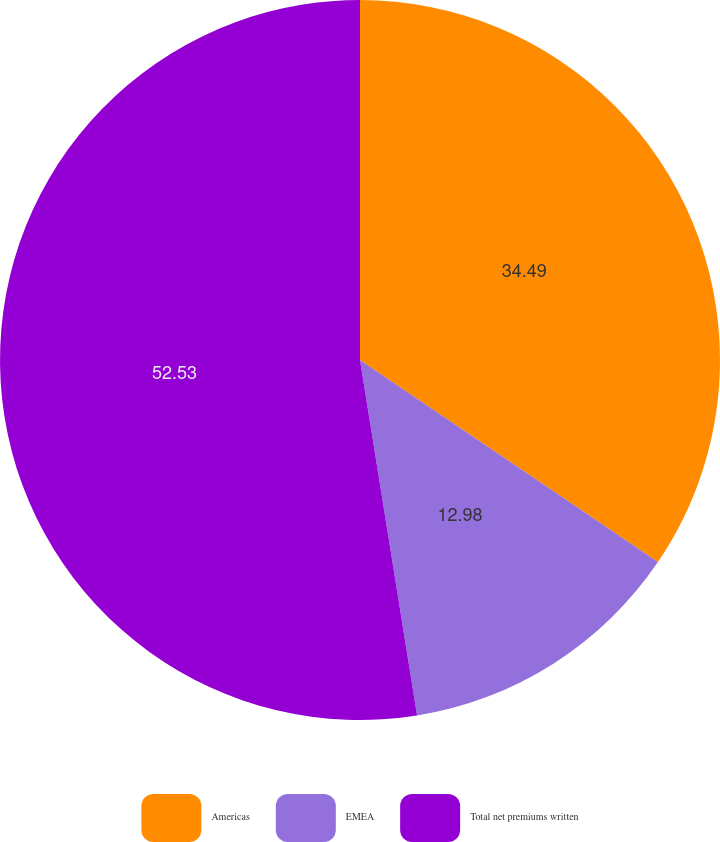Convert chart to OTSL. <chart><loc_0><loc_0><loc_500><loc_500><pie_chart><fcel>Americas<fcel>EMEA<fcel>Total net premiums written<nl><fcel>34.49%<fcel>12.98%<fcel>52.54%<nl></chart> 